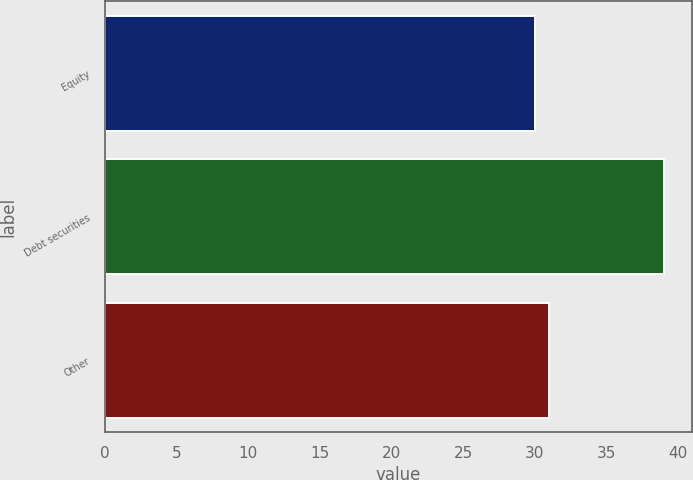Convert chart to OTSL. <chart><loc_0><loc_0><loc_500><loc_500><bar_chart><fcel>Equity<fcel>Debt securities<fcel>Other<nl><fcel>30<fcel>39<fcel>31<nl></chart> 